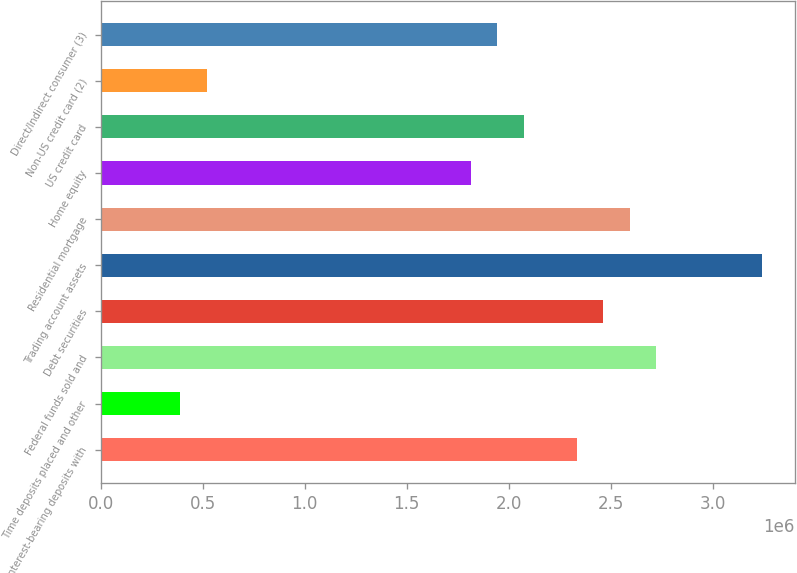<chart> <loc_0><loc_0><loc_500><loc_500><bar_chart><fcel>Interest-bearing deposits with<fcel>Time deposits placed and other<fcel>Federal funds sold and<fcel>Debt securities<fcel>Trading account assets<fcel>Residential mortgage<fcel>Home equity<fcel>US credit card<fcel>Non-US credit card (2)<fcel>Direct/Indirect consumer (3)<nl><fcel>2.33353e+06<fcel>390165<fcel>2.7222e+06<fcel>2.46309e+06<fcel>3.24043e+06<fcel>2.59264e+06<fcel>1.8153e+06<fcel>2.07441e+06<fcel>519722<fcel>1.94486e+06<nl></chart> 